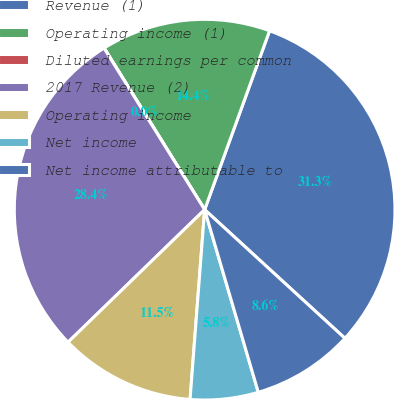<chart> <loc_0><loc_0><loc_500><loc_500><pie_chart><fcel>Revenue (1)<fcel>Operating income (1)<fcel>Diluted earnings per common<fcel>2017 Revenue (2)<fcel>Operating income<fcel>Net income<fcel>Net income attributable to<nl><fcel>31.27%<fcel>14.4%<fcel>0.01%<fcel>28.39%<fcel>11.52%<fcel>5.77%<fcel>8.64%<nl></chart> 